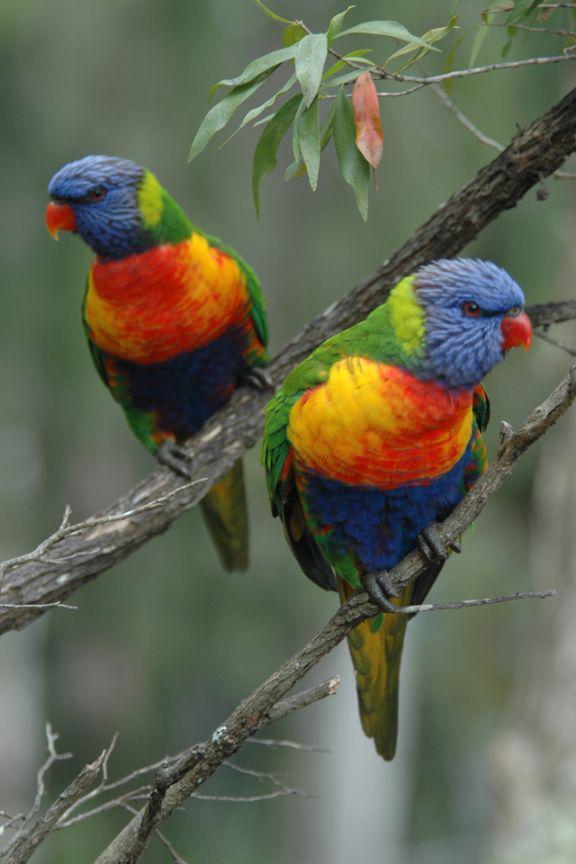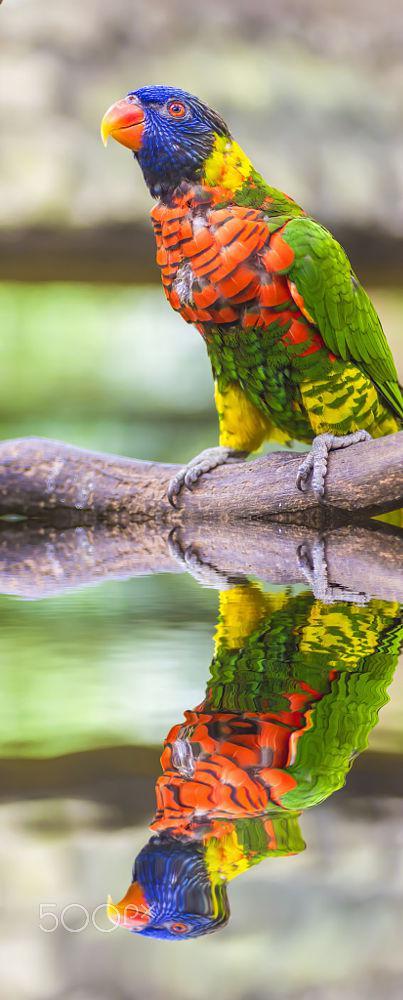The first image is the image on the left, the second image is the image on the right. Evaluate the accuracy of this statement regarding the images: "Some birds are touching each other in at least one photo.". Is it true? Answer yes or no. No. The first image is the image on the left, the second image is the image on the right. For the images shown, is this caption "The left image contains only one multi-colored parrot." true? Answer yes or no. No. 